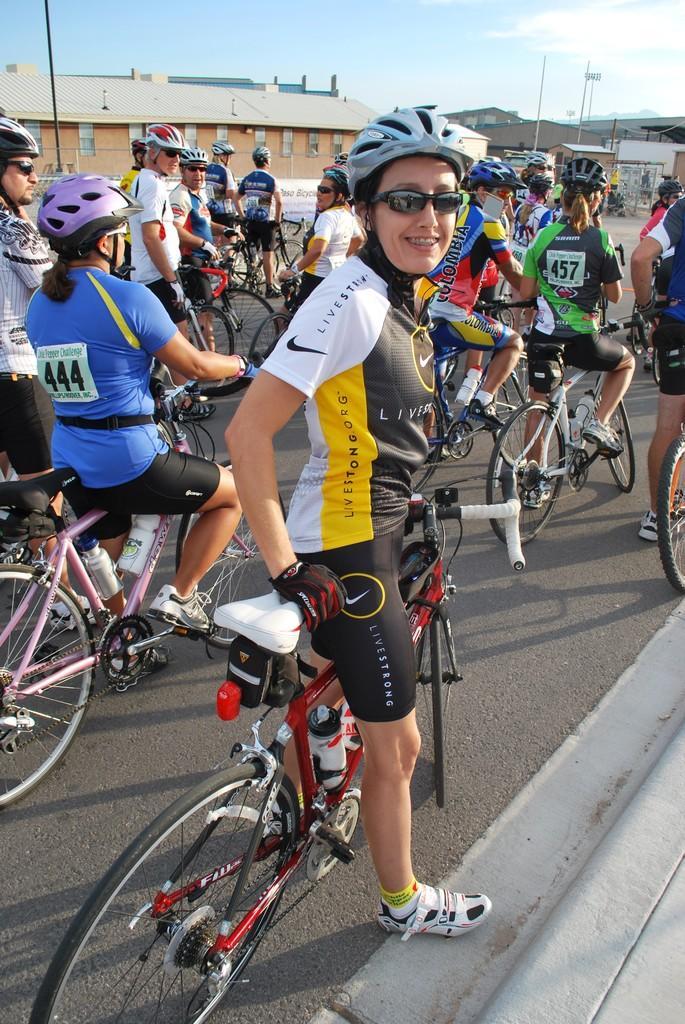In one or two sentences, can you explain what this image depicts? There are many persons holding cycle and standing. A person in the front is wearing white and black dress. She is having a goggles, helmet and a gloves. In the background there are buildings, poles and sky. 